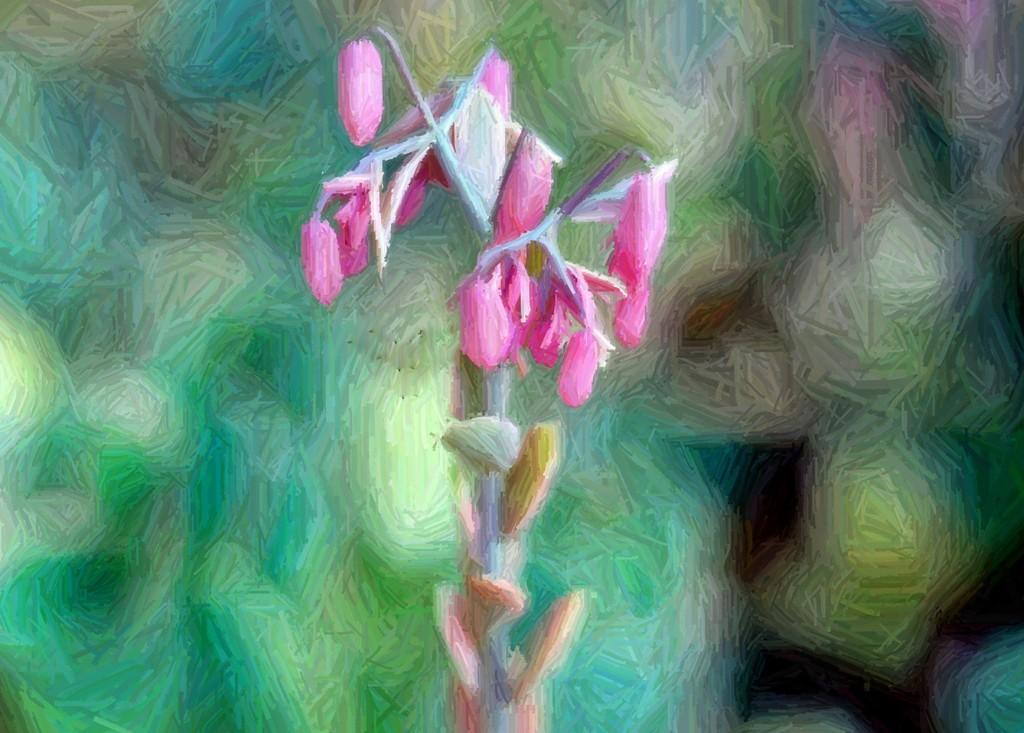What type of artwork is shown in the image? The image is a painting. What is the main subject of the painting? The painting depicts a pink color flower plant. What type of battle is taking place in the painting? There is no battle depicted in the painting; it features a pink color flower plant. How many yaks are visible in the painting? There are no yaks present in the painting; it features a pink color flower plant. 